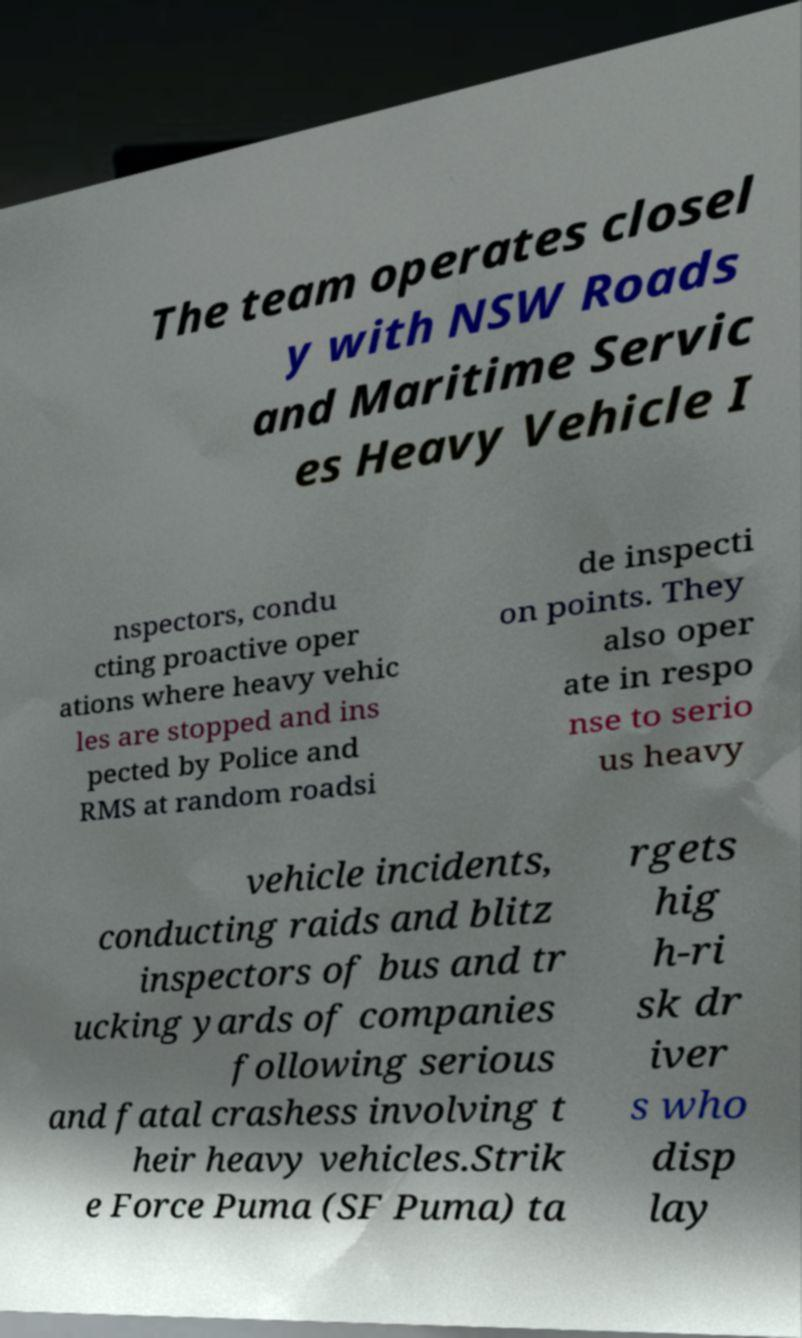What messages or text are displayed in this image? I need them in a readable, typed format. The team operates closel y with NSW Roads and Maritime Servic es Heavy Vehicle I nspectors, condu cting proactive oper ations where heavy vehic les are stopped and ins pected by Police and RMS at random roadsi de inspecti on points. They also oper ate in respo nse to serio us heavy vehicle incidents, conducting raids and blitz inspectors of bus and tr ucking yards of companies following serious and fatal crashess involving t heir heavy vehicles.Strik e Force Puma (SF Puma) ta rgets hig h-ri sk dr iver s who disp lay 